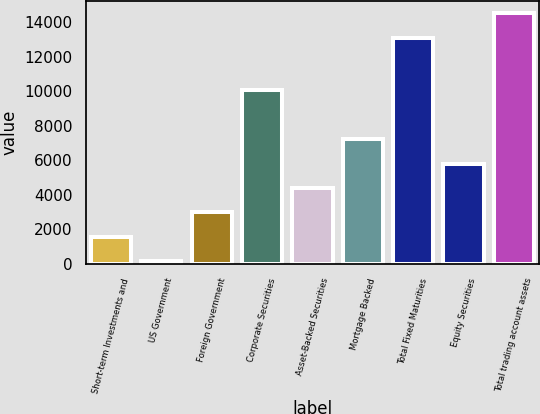Convert chart to OTSL. <chart><loc_0><loc_0><loc_500><loc_500><bar_chart><fcel>Short-term Investments and<fcel>US Government<fcel>Foreign Government<fcel>Corporate Securities<fcel>Asset-Backed Securities<fcel>Mortgage Backed<fcel>Total Fixed Maturities<fcel>Equity Securities<fcel>Total trading account assets<nl><fcel>1580.9<fcel>173<fcel>2988.8<fcel>10089<fcel>4396.7<fcel>7212.5<fcel>13120<fcel>5804.6<fcel>14527.9<nl></chart> 